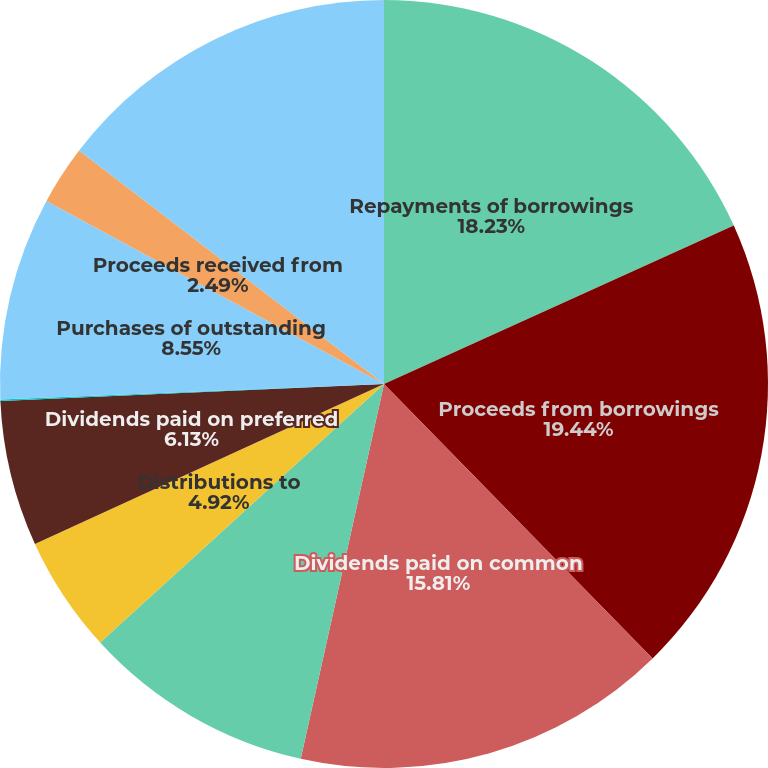Convert chart to OTSL. <chart><loc_0><loc_0><loc_500><loc_500><pie_chart><fcel>Repayments of borrowings<fcel>Proceeds from borrowings<fcel>Dividends paid on common<fcel>Contributions from<fcel>Distributions to<fcel>Dividends paid on preferred<fcel>Debt issuance and other costs<fcel>Purchases of outstanding<fcel>Proceeds received from<fcel>Acquisition of convertible<nl><fcel>18.23%<fcel>19.44%<fcel>15.81%<fcel>9.76%<fcel>4.92%<fcel>6.13%<fcel>0.07%<fcel>8.55%<fcel>2.49%<fcel>14.6%<nl></chart> 